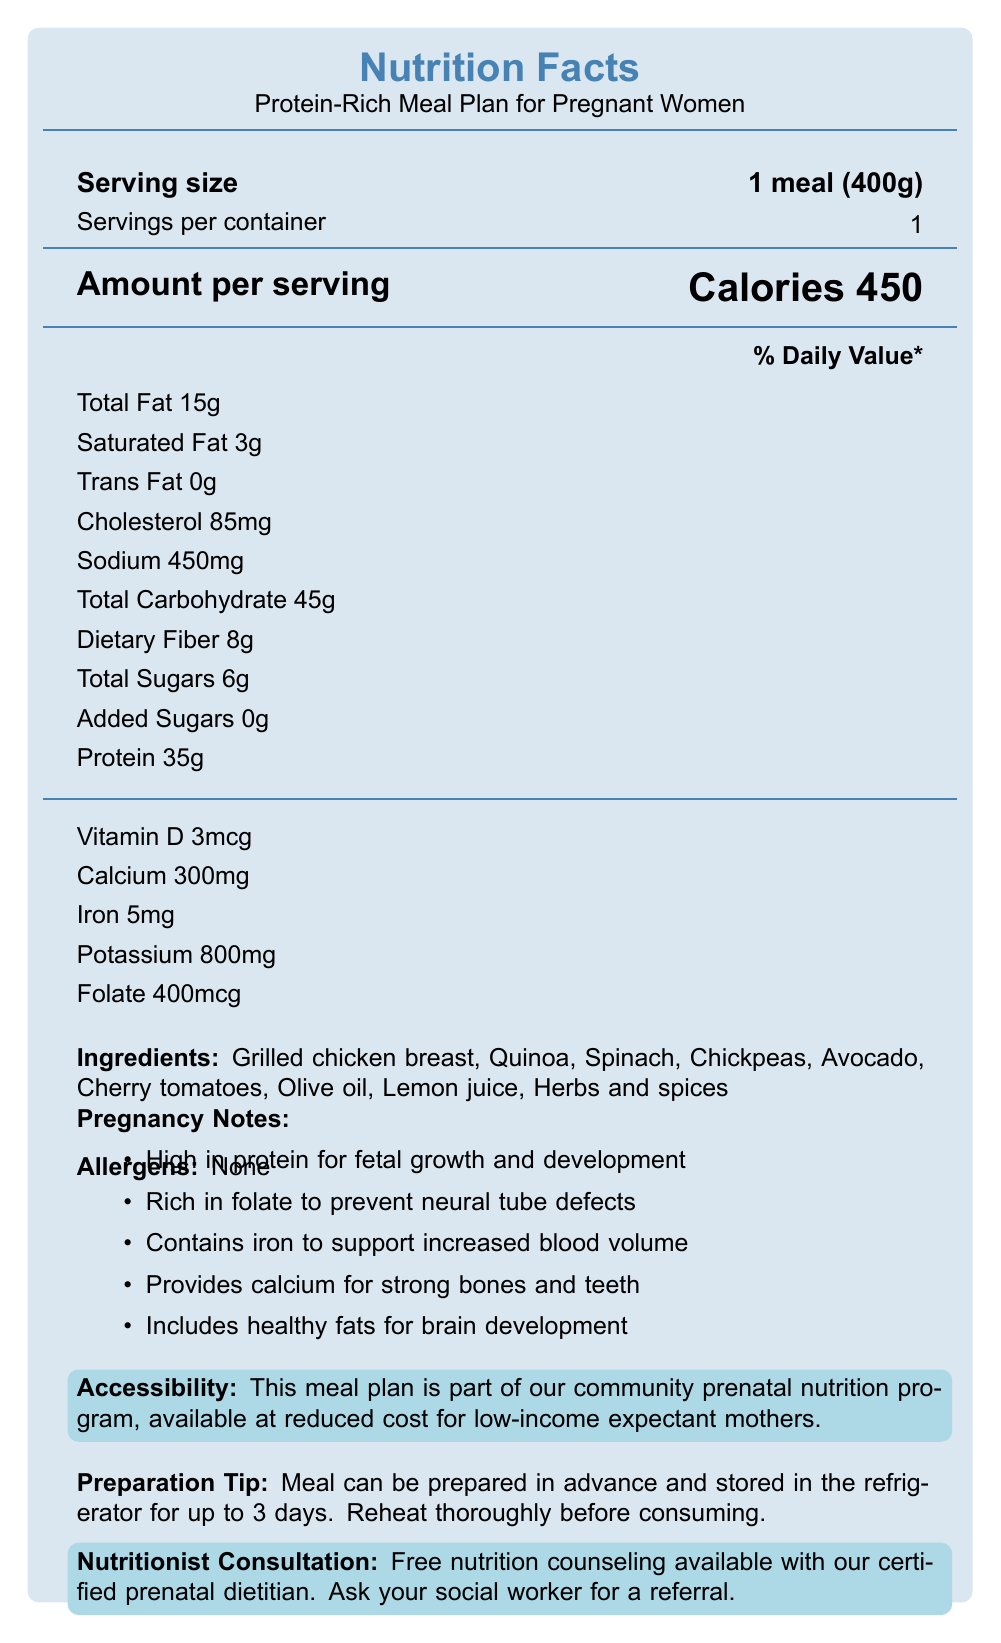What is the serving size? The serving size mentioned on the label is 1 meal (400g).
Answer: 1 meal (400g) How many calories are in one serving? According to the label, one serving contains 450 calories.
Answer: 450 calories What allergens are present in this meal plan? The allergens section clearly states "None".
Answer: None How much protein does this meal contain? The meal contains 35g of protein as indicated in the protein section of the Nutrition Facts.
Answer: 35g What is the percentage of the daily value for folate in one serving? The folate content in one serving is 400mcg, which is 100% of the daily value.
Answer: 100% What are the ingredients in this meal plan? The ingredients listed are Grilled chicken breast, Quinoa, Spinach, Chickpeas, Avocado, Cherry tomatoes, Olive oil, Lemon juice, and Herbs and spices.
Answer: Grilled chicken breast, Quinoa, Spinach, Chickpeas, Avocado, Cherry tomatoes, Olive oil, Lemon juice, Herbs and spices How many grams of dietary fiber does this meal have? The dietary fiber content of the meal is 8g.
Answer: 8g Which of the following is NOT included in this meal plan?
A. Grilled chicken breast
B. Quinoa
C. Beef
D. Avocado Beef is not listed among the ingredients of the meal plan.
Answer: C. Beef What percentage of the daily value of iron does this meal provide?
A. 23%
B. 28%
C. 29%
D. 100% The meal provides 28% of the daily value for iron, as stated on the label.
Answer: B. 28% Is this meal suitable for low-income expectant mothers? The document mentions that the meal plan is part of a community prenatal nutrition program available at reduced cost for low-income expectant mothers.
Answer: Yes Summarize the purpose and key features of this document. The document is designed to inform pregnant women and their caretakers about the nutritional benefits and contents of a specific protein-rich meal, promoting its use within a community prenatal nutrition program.
Answer: The document provides a nutrition facts label for a protein-rich meal plan designed for pregnant women. It outlines the serving size, calorie content, macronutrients, vitamins, and minerals. The meal plan includes ingredients like grilled chicken breast and quinoa, and highlights its benefits for pregnancy, such as high protein for fetal growth and folate for preventing neural tube defects. Additionally, it offers access to reduced-cost meals for low-income expectant mothers and free nutrition counseling. What is the total fat content in this meal? The total fat content per serving is listed as 15g.
Answer: 15g How many days can this meal be stored in the refrigerator? According to the preparation tips, the meal can be prepared in advance and stored in the refrigerator for up to 3 days.
Answer: Up to 3 days Does this meal contain added sugars? The label states that the meal contains 0g of added sugars.
Answer: No What is the main source of protein in this meal plan? The primary ingredient listed that is high in protein is grilled chicken breast.
Answer: Grilled chicken breast What are the benefits of this meal plan during pregnancy? The pregnancy notes section lists the benefits as high in protein for fetal growth and development, rich in folate to prevent neural tube defects, contains iron to support increased blood volume, provides calcium for strong bones and teeth, and includes healthy fats for brain development.
Answer: High in protein for fetal growth, rich in folate to prevent neural tube defects, contains iron to support increased blood volume, provides calcium for strong bones and teeth, includes healthy fats for brain development. How much calcium does one serving contain? One serving of the meal contains 300mg of calcium.
Answer: 300mg What is the sodium content of this meal per serving? The sodium content per serving is listed as 450mg.
Answer: 450mg How much potassium is in this meal? The potassium content in this meal is 800mg.
Answer: 800mg What is the daily value percentage for vitamin D in this meal plan? The meal provides 3mcg of vitamin D, which is 15% of the daily value.
Answer: 15% How can expectant mothers get referred to a nutritionist for free counseling? The section on nutritionist consultation states that free nutrition counseling is available, and expectant mothers should ask their social worker for a referral.
Answer: Ask your social worker for a referral What specific type of diet does the document prescribe? The main title and details in the document specify a protein-rich meal plan intended for pregnant women, emphasizing its nutritional benefits during pregnancy.
Answer: The document prescribes a protein-rich meal plan designed for pregnant women What percentage of the daily value is the added sugars content? The added sugars content in this meal is listed as 0g, which is 0% of the daily value.
Answer: 0% Can you determine the cost of the meal plan from the document? The document mentions that the meal plan is available at reduced cost for low-income expectant mothers but does not specify the actual cost.
Answer: Not enough information 